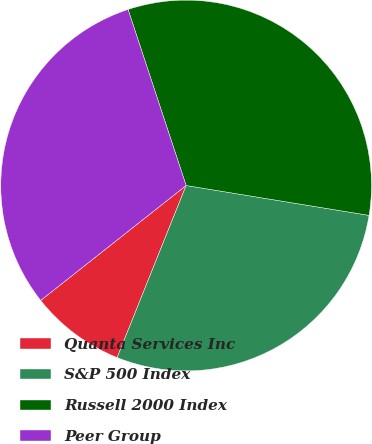Convert chart. <chart><loc_0><loc_0><loc_500><loc_500><pie_chart><fcel>Quanta Services Inc<fcel>S&P 500 Index<fcel>Russell 2000 Index<fcel>Peer Group<nl><fcel>8.29%<fcel>28.49%<fcel>32.65%<fcel>30.57%<nl></chart> 